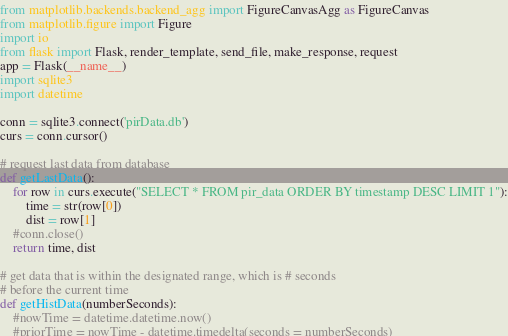Convert code to text. <code><loc_0><loc_0><loc_500><loc_500><_Python_>from matplotlib.backends.backend_agg import FigureCanvasAgg as FigureCanvas
from matplotlib.figure import Figure
import io
from flask import Flask, render_template, send_file, make_response, request
app = Flask(__name__)
import sqlite3
import datetime

conn = sqlite3.connect('pirData.db')
curs = conn.cursor()

# request last data from database
def getLastData():
	for row in curs.execute("SELECT * FROM pir_data ORDER BY timestamp DESC LIMIT 1"):
		time = str(row[0])
		dist = row[1]
	#conn.close()
	return time, dist

# get data that is within the designated range, which is # seconds 
# before the current time
def getHistData(numberSeconds):
	#nowTime = datetime.datetime.now()
	#priorTime = nowTime - datetime.timedelta(seconds = numberSeconds)</code> 